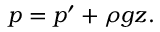Convert formula to latex. <formula><loc_0><loc_0><loc_500><loc_500>p = p ^ { \prime } + \rho g z .</formula> 